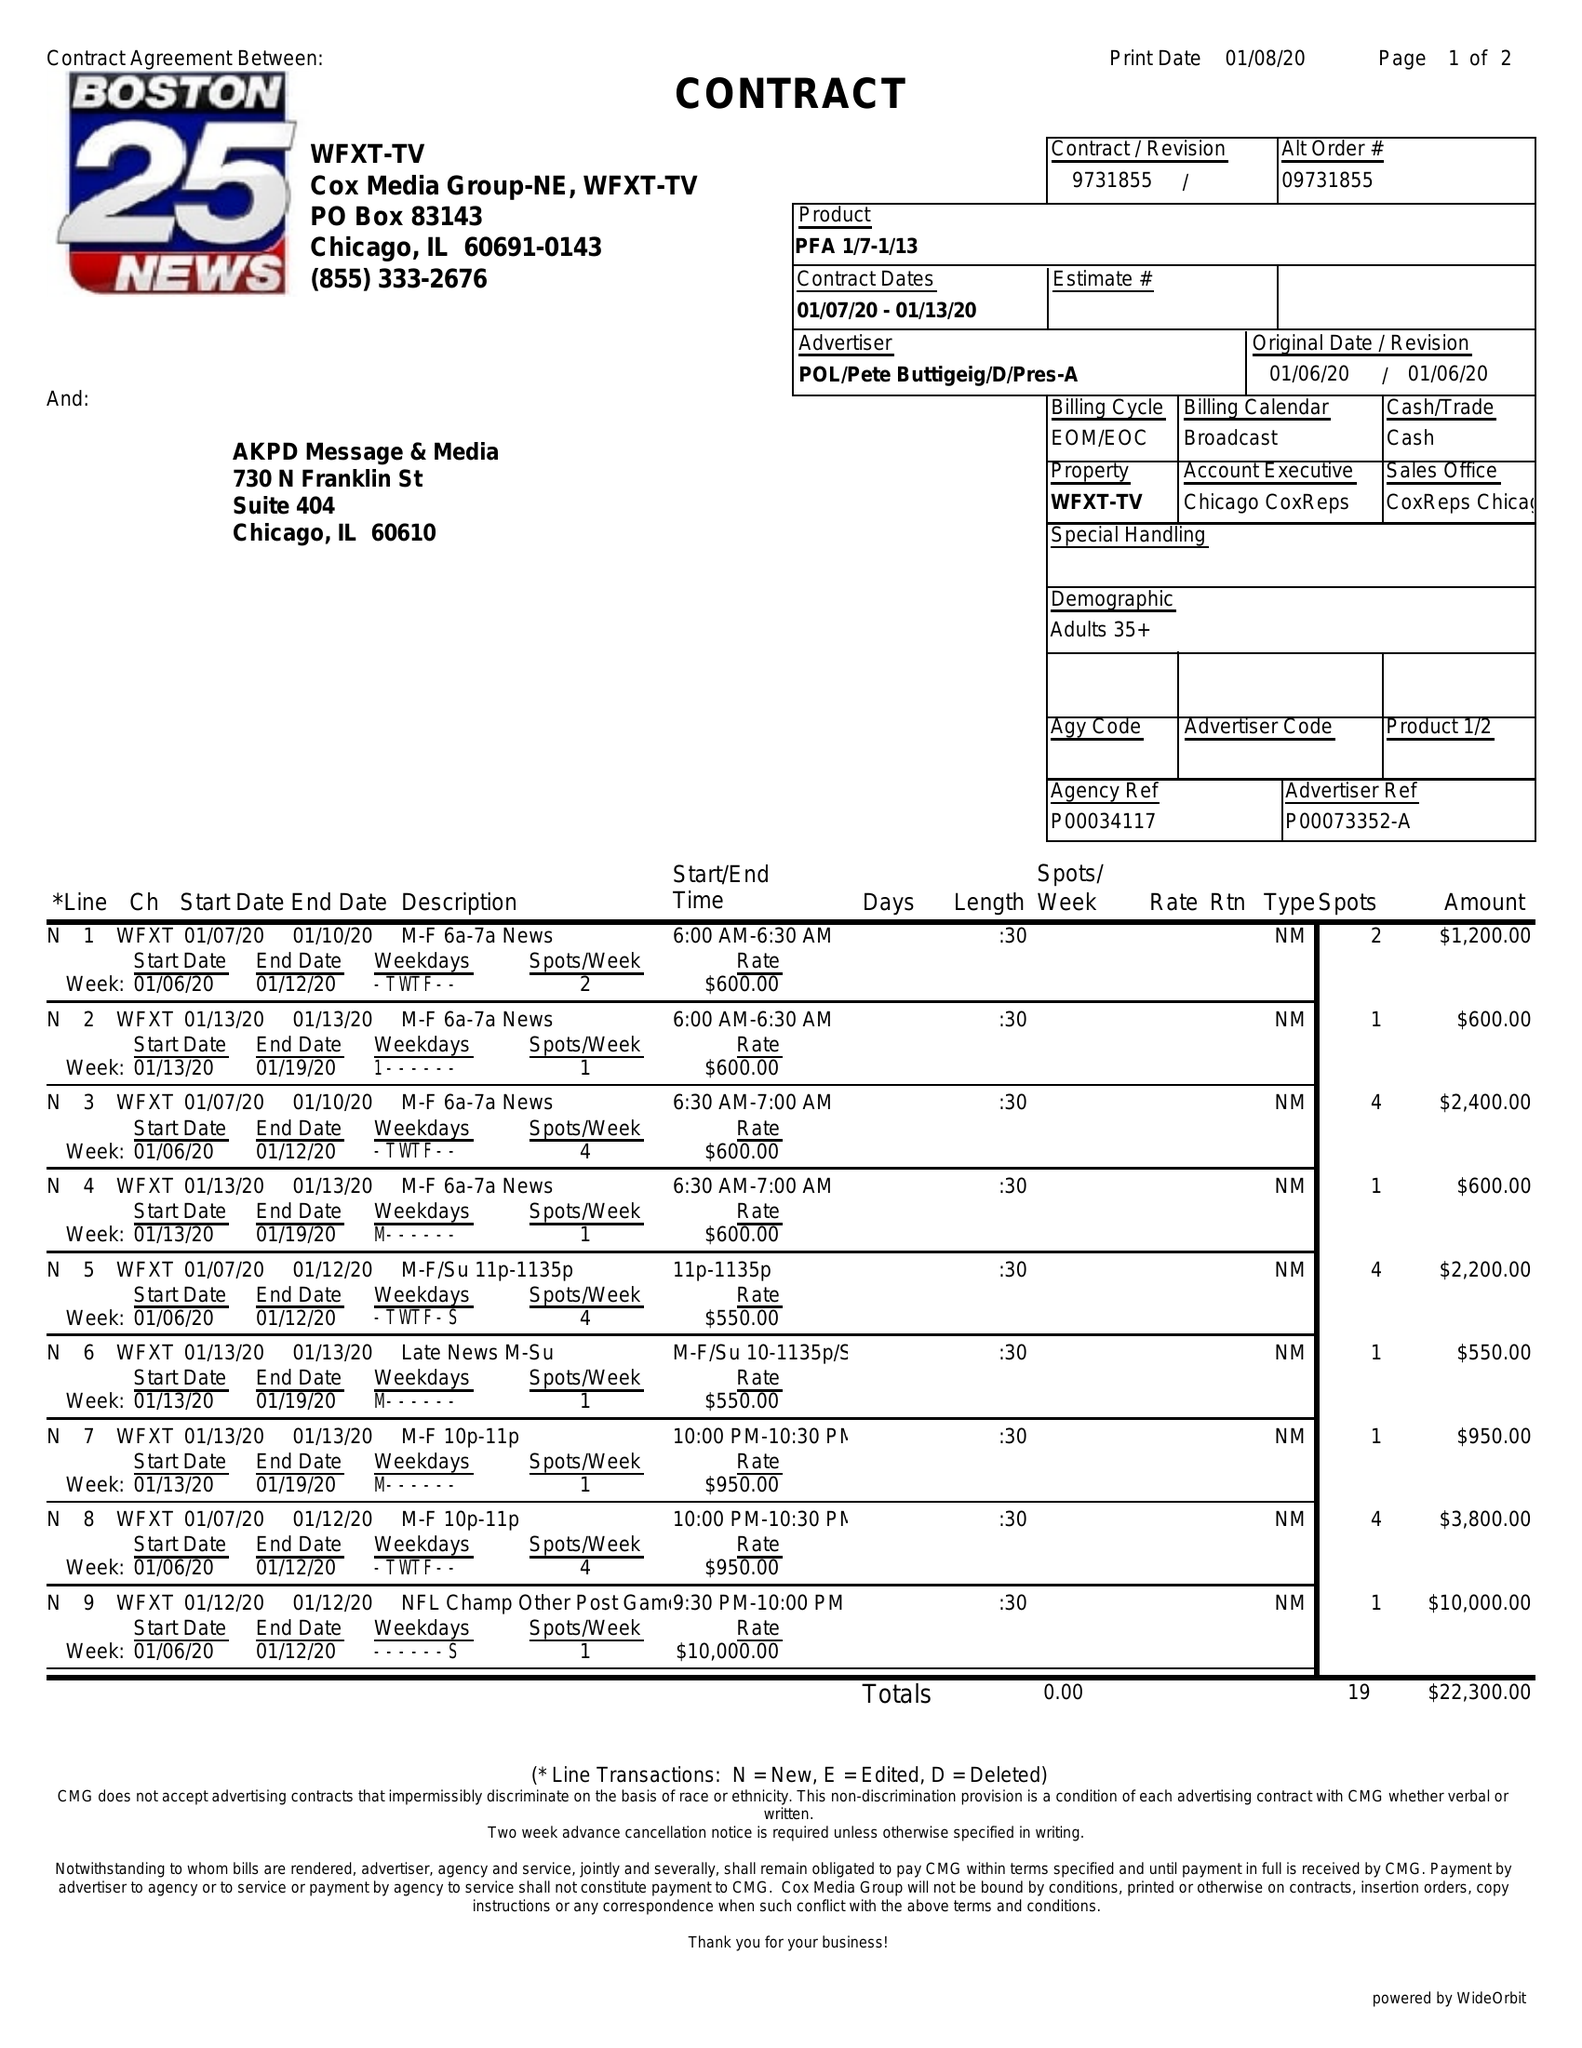What is the value for the flight_to?
Answer the question using a single word or phrase. 01/13/20 